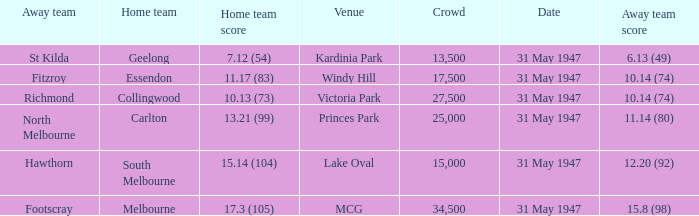What is the listed crowd when hawthorn is away? 1.0. 